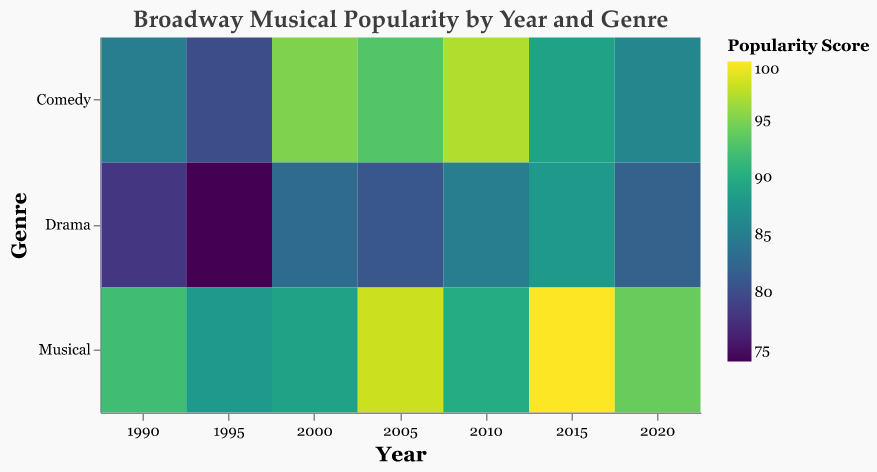What is the title of the heatmap? The title is usually placed prominently at the top of the figure and provides a summary of what the heatmap represents.
Answer: Broadway Musical Popularity by Year and Genre Which show had the highest popularity score in 2015? Look for the year 2015 on the x-axis, then find the musical genre row, and identify the show with the highest score in that year.
Answer: Hamilton How does the popularity of Comedies in 2000 compare to Musicals in 2005? Find the cells that represent Comedies in 2000 and Musicals in 2005. Compare the color intensity corresponding to the popularity scores of 'The Producers' and 'Wicked', respectively.
Answer: Wicked is more popular than The Producers What is the average popularity score of Musicals across all the years? Find all the cells in the Musical row, sum their popularity scores, and divide by the number of Musicals. (92 + 88 + 89 + 98 + 90 + 100 + 94) / 7 = 651 / 7 = 93
Answer: 93 Which genre had the least popular show in 1995? Locate the year 1995 on the x-axis, then identify the cell with the lowest color intensity (lowest score) in that year.
Answer: Drama What is the difference in popularity score between 'Sunset Boulevard' and 'Damn Yankees' in 1995? Find the scores for 'Sunset Boulevard' (Musical) and 'Damn Yankees' (Comedy) in 1995 and subtract the smaller score from the larger score. (88 - 80) = 8
Answer: 8 What trend do you notice in the popularity of Drama genre from 1990 to 2020? Observe the colors in the Drama row for each year from 1990 to 2020 to find any noticeable patterns – either increasing or decreasing popularity.
Answer: Generally increasing Which year had the highest average popularity score across all genres? Calculate the average popularity score for each year and compare them. Sum the scores for each year and divide by the number of genres per year. For example, 2020 has (86 + 82 + 94) / 3 = 87.33. Do similar calculations for other years.
Answer: 2015 (in more detailed calculation: 93.67 vs other years lower) How many unique musicals are represented in the heatmap? Count the number of distinct shows within the Musicals genre across all years.
Answer: 7 